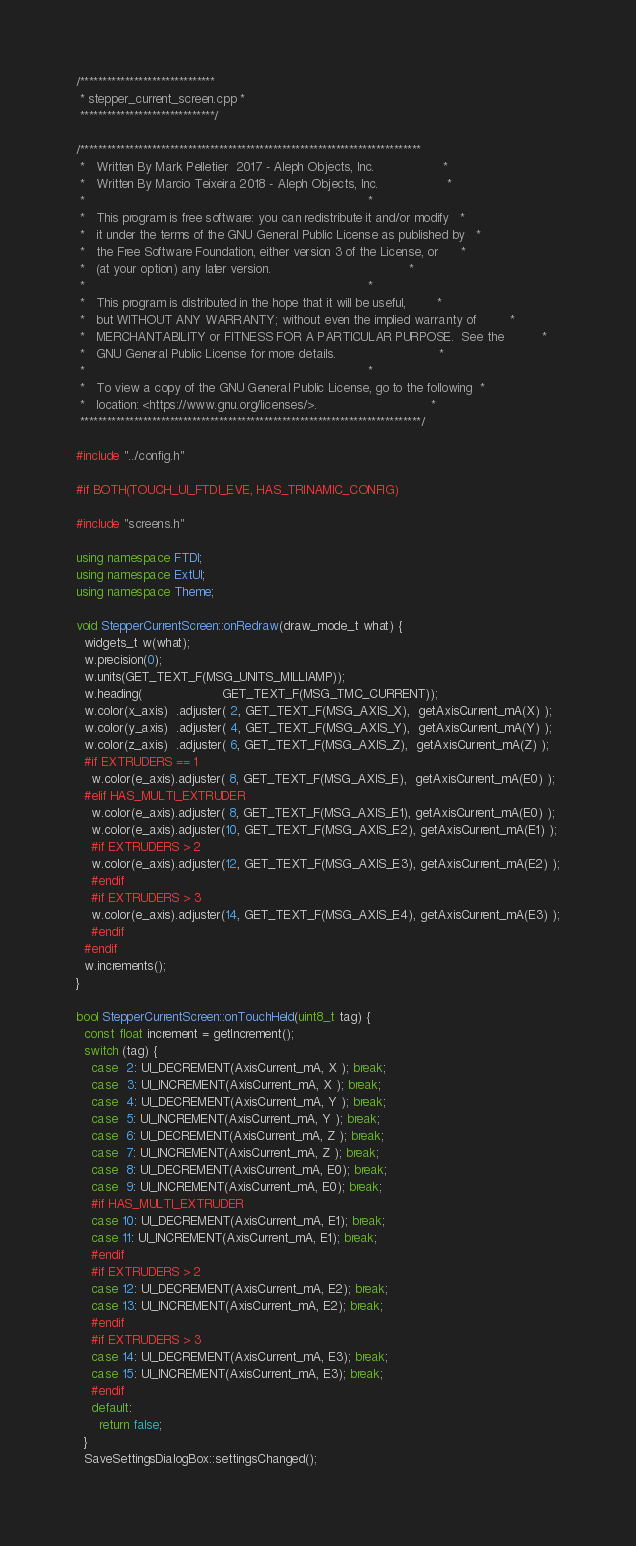Convert code to text. <code><loc_0><loc_0><loc_500><loc_500><_C++_>/******************************
 * stepper_current_screen.cpp *
 ******************************/

/****************************************************************************
 *   Written By Mark Pelletier  2017 - Aleph Objects, Inc.                  *
 *   Written By Marcio Teixeira 2018 - Aleph Objects, Inc.                  *
 *                                                                          *
 *   This program is free software: you can redistribute it and/or modify   *
 *   it under the terms of the GNU General Public License as published by   *
 *   the Free Software Foundation, either version 3 of the License, or      *
 *   (at your option) any later version.                                    *
 *                                                                          *
 *   This program is distributed in the hope that it will be useful,        *
 *   but WITHOUT ANY WARRANTY; without even the implied warranty of         *
 *   MERCHANTABILITY or FITNESS FOR A PARTICULAR PURPOSE.  See the          *
 *   GNU General Public License for more details.                           *
 *                                                                          *
 *   To view a copy of the GNU General Public License, go to the following  *
 *   location: <https://www.gnu.org/licenses/>.                              *
 ****************************************************************************/

#include "../config.h"

#if BOTH(TOUCH_UI_FTDI_EVE, HAS_TRINAMIC_CONFIG)

#include "screens.h"

using namespace FTDI;
using namespace ExtUI;
using namespace Theme;

void StepperCurrentScreen::onRedraw(draw_mode_t what) {
  widgets_t w(what);
  w.precision(0);
  w.units(GET_TEXT_F(MSG_UNITS_MILLIAMP));
  w.heading(                     GET_TEXT_F(MSG_TMC_CURRENT));
  w.color(x_axis)  .adjuster( 2, GET_TEXT_F(MSG_AXIS_X),  getAxisCurrent_mA(X) );
  w.color(y_axis)  .adjuster( 4, GET_TEXT_F(MSG_AXIS_Y),  getAxisCurrent_mA(Y) );
  w.color(z_axis)  .adjuster( 6, GET_TEXT_F(MSG_AXIS_Z),  getAxisCurrent_mA(Z) );
  #if EXTRUDERS == 1
    w.color(e_axis).adjuster( 8, GET_TEXT_F(MSG_AXIS_E),  getAxisCurrent_mA(E0) );
  #elif HAS_MULTI_EXTRUDER
    w.color(e_axis).adjuster( 8, GET_TEXT_F(MSG_AXIS_E1), getAxisCurrent_mA(E0) );
    w.color(e_axis).adjuster(10, GET_TEXT_F(MSG_AXIS_E2), getAxisCurrent_mA(E1) );
    #if EXTRUDERS > 2
    w.color(e_axis).adjuster(12, GET_TEXT_F(MSG_AXIS_E3), getAxisCurrent_mA(E2) );
    #endif
    #if EXTRUDERS > 3
    w.color(e_axis).adjuster(14, GET_TEXT_F(MSG_AXIS_E4), getAxisCurrent_mA(E3) );
    #endif
  #endif
  w.increments();
}

bool StepperCurrentScreen::onTouchHeld(uint8_t tag) {
  const float increment = getIncrement();
  switch (tag) {
    case  2: UI_DECREMENT(AxisCurrent_mA, X ); break;
    case  3: UI_INCREMENT(AxisCurrent_mA, X ); break;
    case  4: UI_DECREMENT(AxisCurrent_mA, Y ); break;
    case  5: UI_INCREMENT(AxisCurrent_mA, Y ); break;
    case  6: UI_DECREMENT(AxisCurrent_mA, Z ); break;
    case  7: UI_INCREMENT(AxisCurrent_mA, Z ); break;
    case  8: UI_DECREMENT(AxisCurrent_mA, E0); break;
    case  9: UI_INCREMENT(AxisCurrent_mA, E0); break;
    #if HAS_MULTI_EXTRUDER
    case 10: UI_DECREMENT(AxisCurrent_mA, E1); break;
    case 11: UI_INCREMENT(AxisCurrent_mA, E1); break;
    #endif
    #if EXTRUDERS > 2
    case 12: UI_DECREMENT(AxisCurrent_mA, E2); break;
    case 13: UI_INCREMENT(AxisCurrent_mA, E2); break;
    #endif
    #if EXTRUDERS > 3
    case 14: UI_DECREMENT(AxisCurrent_mA, E3); break;
    case 15: UI_INCREMENT(AxisCurrent_mA, E3); break;
    #endif
    default:
      return false;
  }
  SaveSettingsDialogBox::settingsChanged();</code> 